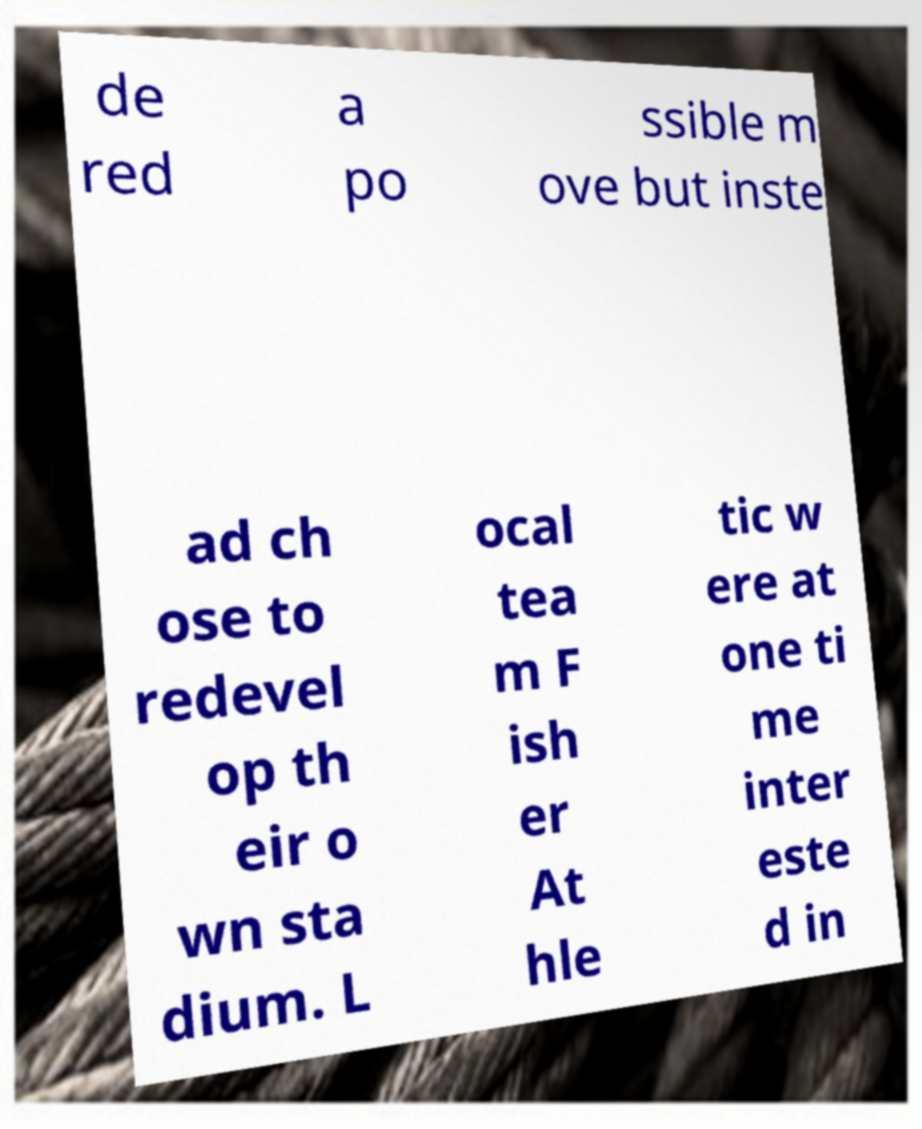Can you read and provide the text displayed in the image?This photo seems to have some interesting text. Can you extract and type it out for me? de red a po ssible m ove but inste ad ch ose to redevel op th eir o wn sta dium. L ocal tea m F ish er At hle tic w ere at one ti me inter este d in 